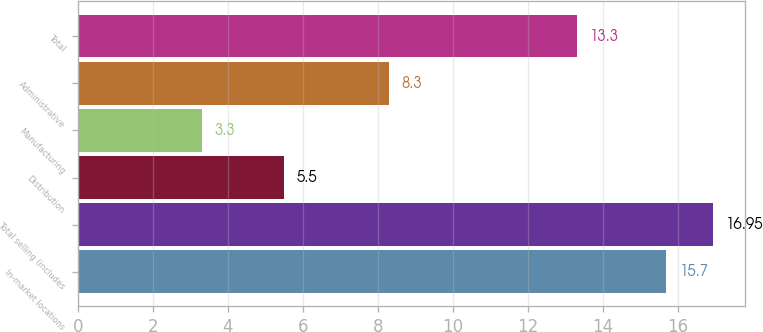<chart> <loc_0><loc_0><loc_500><loc_500><bar_chart><fcel>In-market locations<fcel>Total selling (includes<fcel>Distribution<fcel>Manufacturing<fcel>Administrative<fcel>Total<nl><fcel>15.7<fcel>16.95<fcel>5.5<fcel>3.3<fcel>8.3<fcel>13.3<nl></chart> 